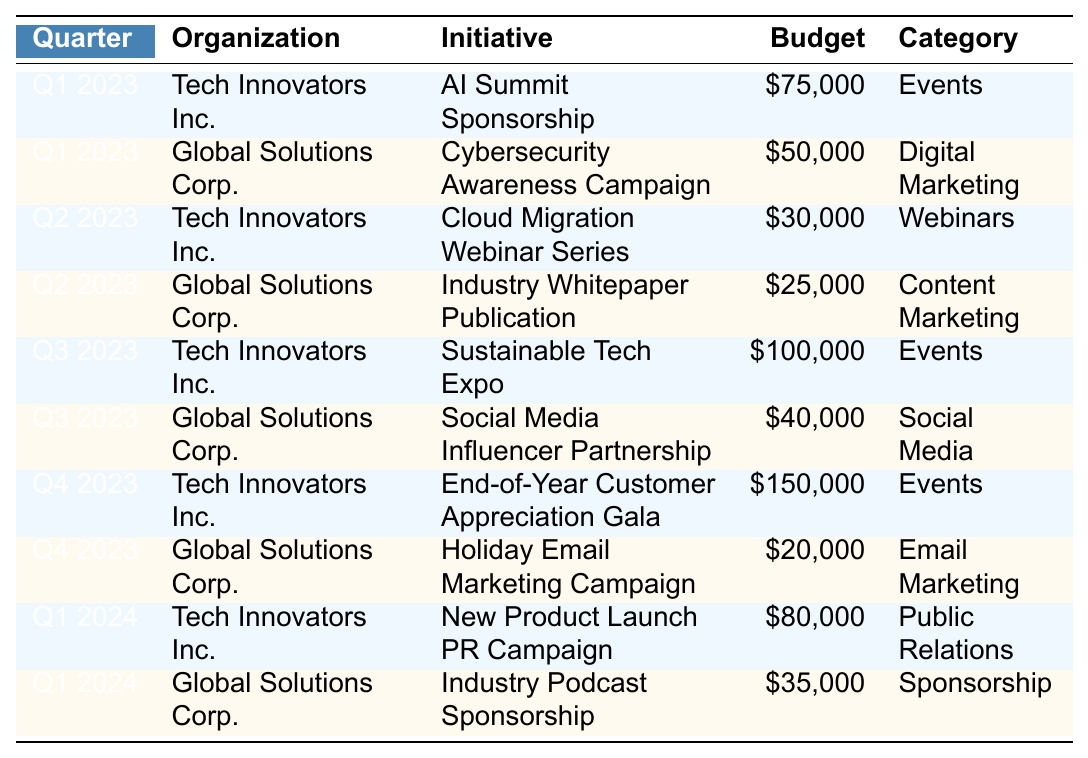What is the total budget allocated by Tech Innovators Inc. in Q4 2023? According to the table, Tech Innovators Inc. allocated $150,000 for the End-of-Year Customer Appreciation Gala in Q4 2023. Since this is the only entry for that organization in that quarter, the total budget is $150,000.
Answer: $150,000 Which initiative received the lowest budget in Q2 2023? In Q2 2023, Tech Innovators Inc. allocated $30,000 for the Cloud Migration Webinar Series, and Global Solutions Corp. allocated $25,000 for the Industry Whitepaper Publication. Comparing these budgets, the lowest is $25,000 for the Industry Whitepaper Publication.
Answer: $25,000 How much budget did Global Solutions Corp. allocate for digital marketing initiatives across all quarters? The digital marketing initiative that Global Solutions Corp. had is the Cybersecurity Awareness Campaign in Q1 2023 ($50,000) and the Holiday Email Marketing Campaign in Q4 2023 ($20,000). By adding these, the total budget is $50,000 + $20,000 = $70,000.
Answer: $70,000 What is the total budget for all initiatives in Q1 2024? In Q1 2024, Tech Innovators Inc. allocated $80,000 for the New Product Launch PR Campaign, and Global Solutions Corp. allocated $35,000 for the Industry Podcast Sponsorship. Adding these amounts gives $80,000 + $35,000 = $115,000 for all initiatives in that quarter.
Answer: $115,000 Is the budget for the Sustainable Tech Expo greater than the combined budget for the other Q3 2023 initiatives? The Sustainable Tech Expo had a budget of $100,000. The other Q3 2023 initiative, the Social Media Influencer Partnership, had a budget of $40,000. The combined budget for the other initiative is $40,000. Comparing these amounts, $100,000 is greater than $40,000, so the statement is true.
Answer: Yes What is the average budget allocated in Q1 2023 across both organizations? In Q1 2023, Tech Innovators Inc. had a budget of $75,000 (AI Summit Sponsorship) and Global Solutions Corp. had $50,000 (Cybersecurity Awareness Campaign). The average budget is calculated as (75,000 + 50,000) / 2 = $62,500.
Answer: $62,500 Which quarter saw the highest combined budget allocation from both organizations? Analyzing the total budget allocations, Q4 2023 has Tech Innovators Inc. with $150,000 and Global Solutions Corp. with $20,000, giving a combined budget of $170,000. Other quarters have lower combined budgets, making Q4 2023 the highest.
Answer: Q4 2023 Did Global Solutions Corp. allocate any budget for events? Upon reviewing the table, Global Solutions Corp. did not allocate any budget for events; all their initiatives fall into categories other than events. Thus, the answer is no.
Answer: No What percentage of the total budget for Tech Innovators Inc. in Q3 2023 is the budget for the Sustainable Tech Expo? The total budget for Tech Innovators Inc. in Q3 2023 includes the Sustainable Tech Expo ($100,000) and considers this as the only initiative for that quarter. Thus, the percentage is (100,000 / 100,000) * 100% = 100%.
Answer: 100% Which organization had a higher total budget allocation in 2023? Tech Innovators Inc. had a total allocation of $75,000 (Q1) + $30,000 (Q2) + $100,000 (Q3) + $150,000 (Q4) = $355,000. Global Solutions Corp. had $50,000 (Q1) + $25,000 (Q2) + $40,000 (Q3) + $20,000 (Q4) = $135,000. Comparing totals shows Tech Innovators Inc. had a higher budget allocation.
Answer: Tech Innovators Inc 